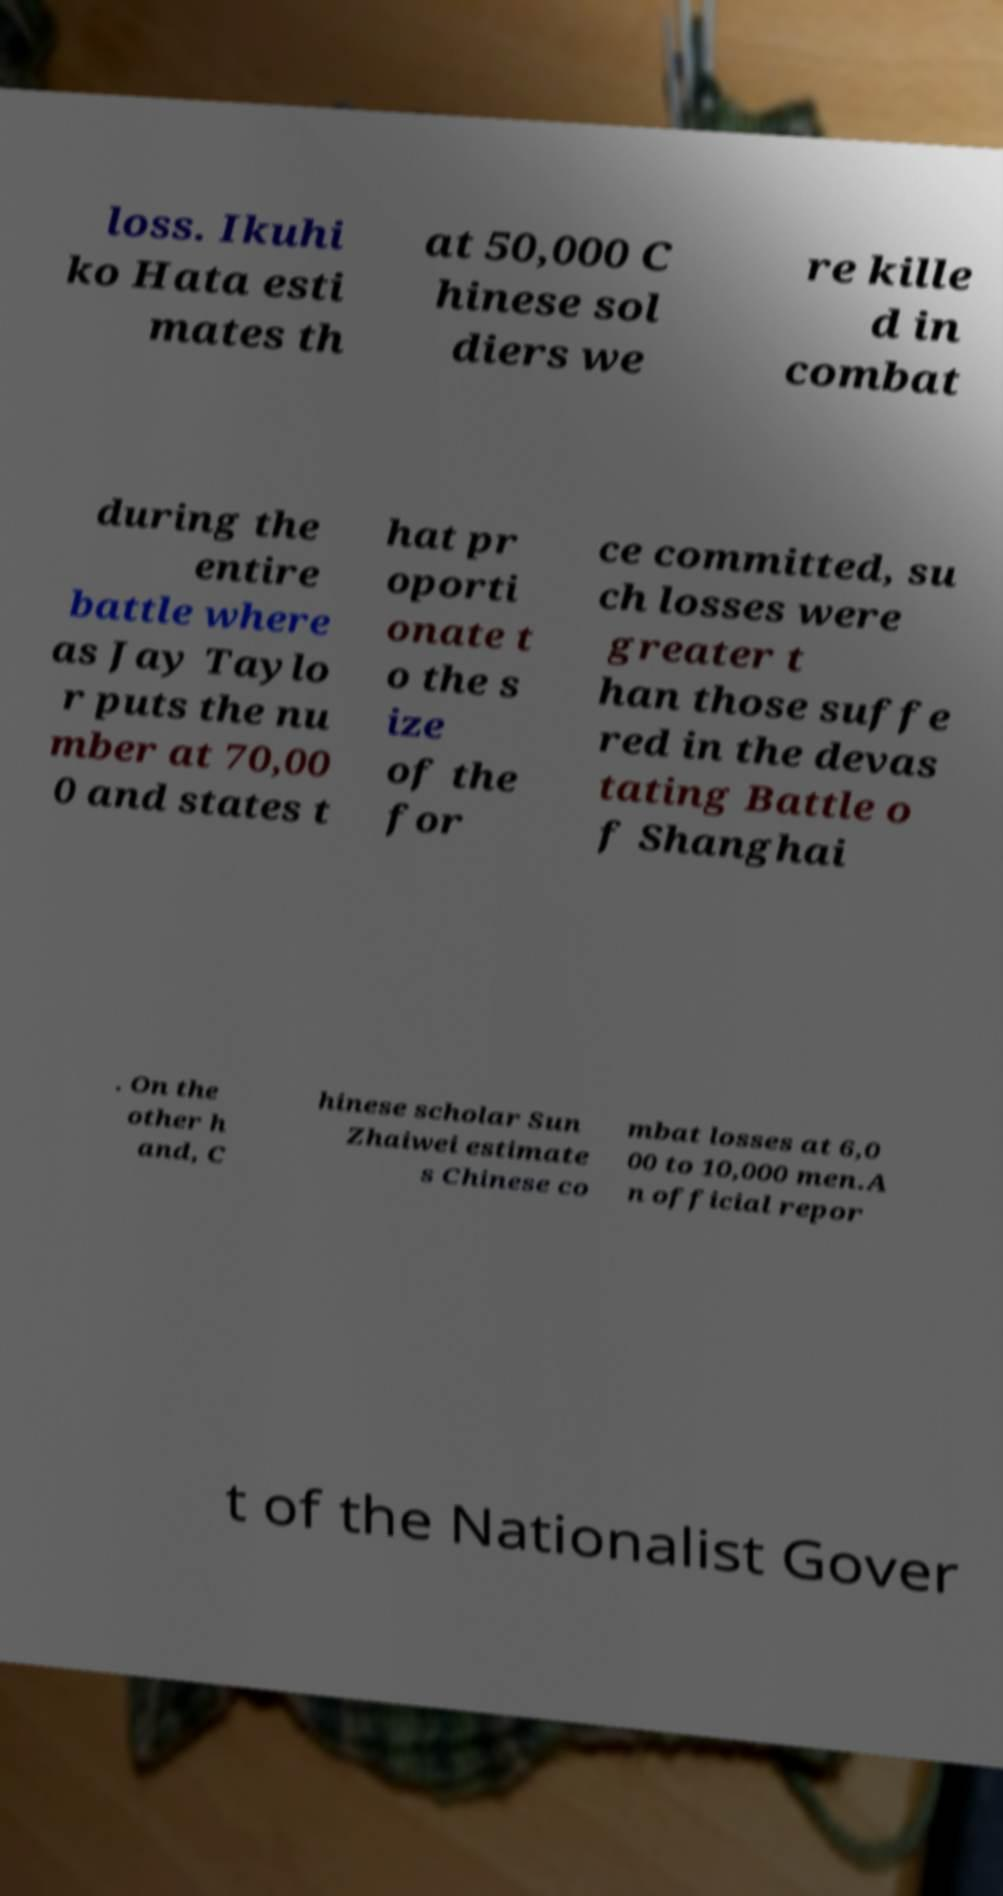What messages or text are displayed in this image? I need them in a readable, typed format. loss. Ikuhi ko Hata esti mates th at 50,000 C hinese sol diers we re kille d in combat during the entire battle where as Jay Taylo r puts the nu mber at 70,00 0 and states t hat pr oporti onate t o the s ize of the for ce committed, su ch losses were greater t han those suffe red in the devas tating Battle o f Shanghai . On the other h and, C hinese scholar Sun Zhaiwei estimate s Chinese co mbat losses at 6,0 00 to 10,000 men.A n official repor t of the Nationalist Gover 